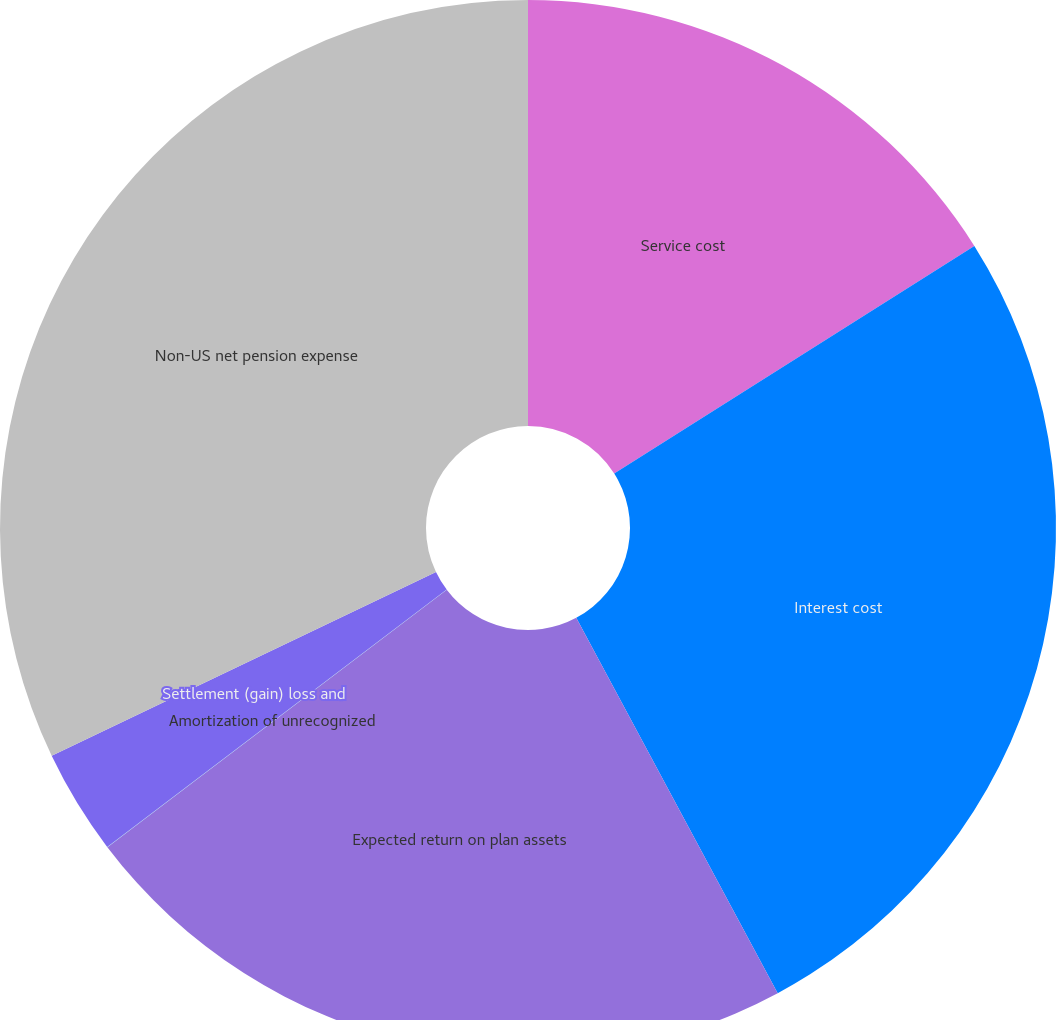<chart> <loc_0><loc_0><loc_500><loc_500><pie_chart><fcel>Service cost<fcel>Interest cost<fcel>Expected return on plan assets<fcel>Amortization of unrecognized<fcel>Settlement (gain) loss and<fcel>Non-US net pension expense<nl><fcel>16.03%<fcel>26.13%<fcel>22.51%<fcel>0.01%<fcel>3.22%<fcel>32.1%<nl></chart> 